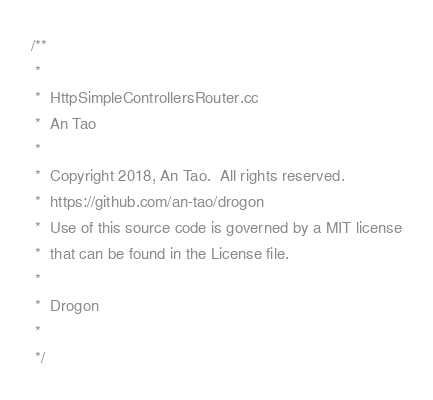<code> <loc_0><loc_0><loc_500><loc_500><_C++_>/**
 *
 *  HttpSimpleControllersRouter.cc
 *  An Tao
 *
 *  Copyright 2018, An Tao.  All rights reserved.
 *  https://github.com/an-tao/drogon
 *  Use of this source code is governed by a MIT license
 *  that can be found in the License file.
 *
 *  Drogon
 *
 */
</code> 